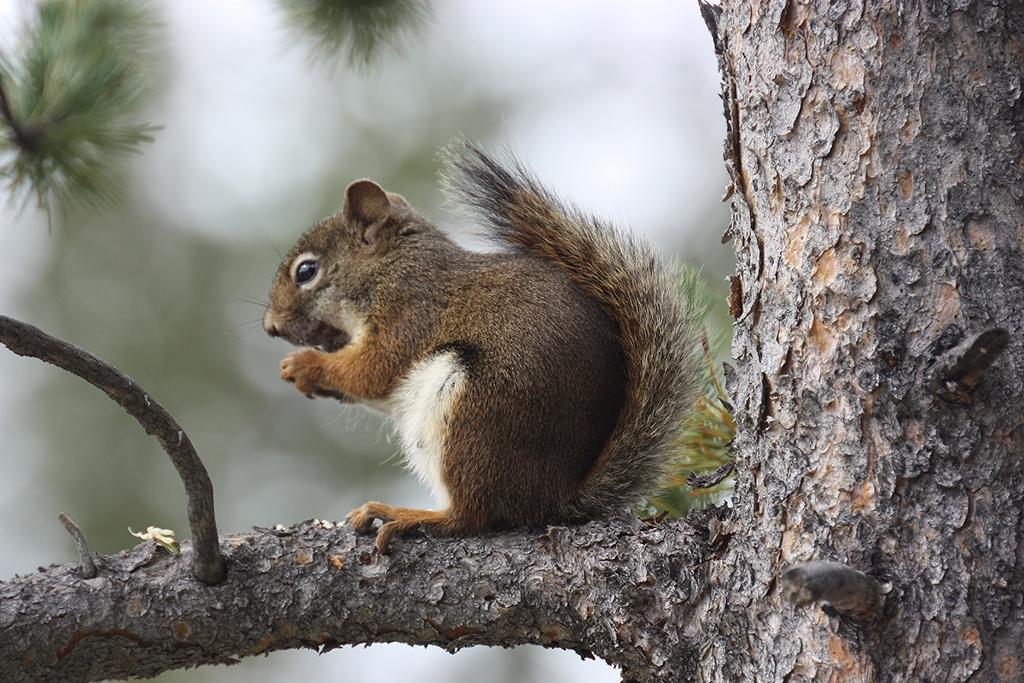Could you give a brief overview of what you see in this image? In this image there is a squirrel which is sitting on the tree stem. At the top there are green leaves. 